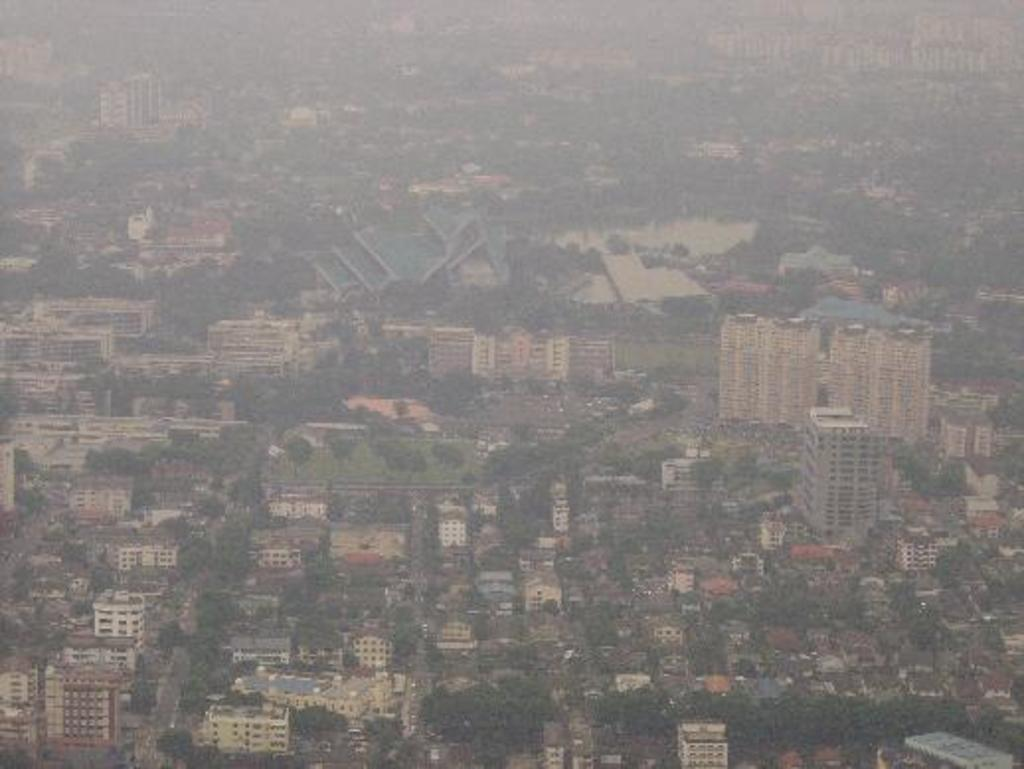What type of natural vegetation is visible in the image? There are many trees in the image. What type of man-made structure can be seen in the image? There is at least one building in the image. What type of porter is carrying a jar in the image? There is no porter or jar present in the image. What is the taste of the trees in the image? Trees do not have a taste, as they are plants and not food items. 